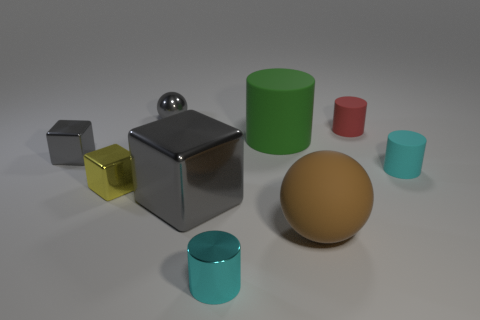Is the metal ball the same color as the large metal object?
Your response must be concise. Yes. What material is the other cylinder that is the same color as the small shiny cylinder?
Make the answer very short. Rubber. Is there a brown rubber ball of the same size as the red thing?
Offer a terse response. No. Are there any green matte cylinders left of the tiny cylinder left of the red cylinder?
Give a very brief answer. No. What number of blocks are either small gray metallic things or tiny red rubber things?
Your answer should be compact. 1. Are there any yellow shiny things that have the same shape as the small red thing?
Give a very brief answer. No. What is the shape of the tiny cyan metallic object?
Make the answer very short. Cylinder. What number of objects are gray cubes or small cyan metallic things?
Provide a short and direct response. 3. There is a gray shiny object on the left side of the yellow shiny block; is its size the same as the ball that is in front of the tiny red rubber cylinder?
Ensure brevity in your answer.  No. What number of other things are the same material as the small red cylinder?
Give a very brief answer. 3. 